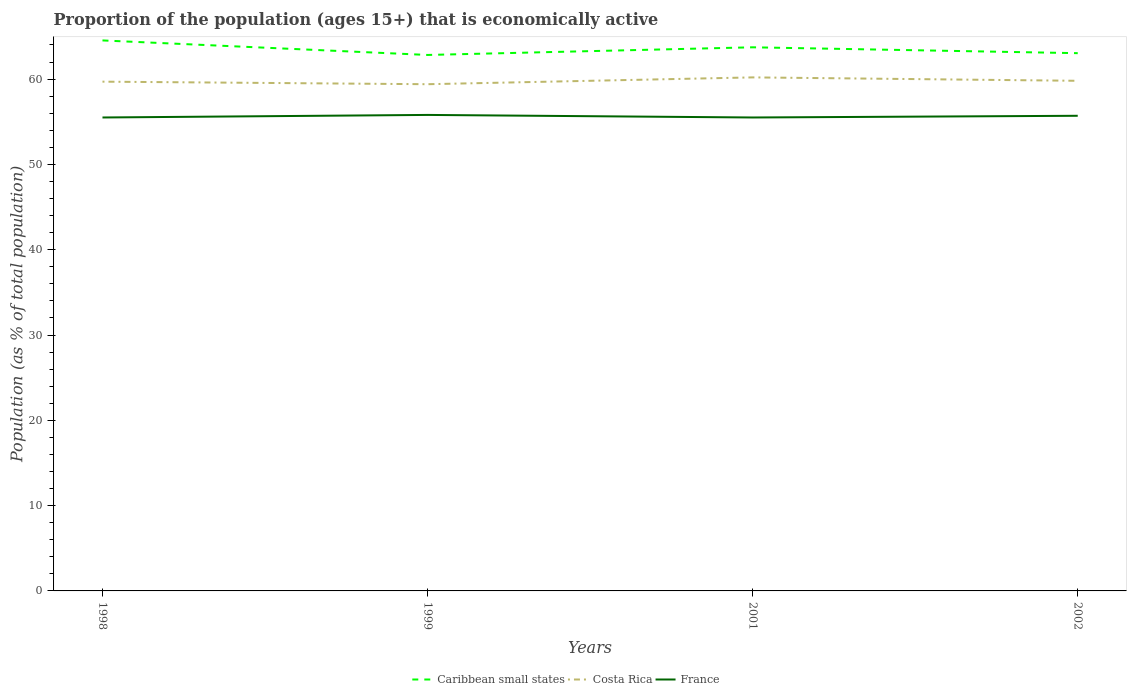How many different coloured lines are there?
Your answer should be compact. 3. Across all years, what is the maximum proportion of the population that is economically active in Costa Rica?
Make the answer very short. 59.4. What is the total proportion of the population that is economically active in France in the graph?
Offer a terse response. -0.2. What is the difference between the highest and the second highest proportion of the population that is economically active in France?
Your answer should be compact. 0.3. What is the difference between the highest and the lowest proportion of the population that is economically active in Caribbean small states?
Your answer should be very brief. 2. Is the proportion of the population that is economically active in France strictly greater than the proportion of the population that is economically active in Costa Rica over the years?
Your answer should be very brief. Yes. How many lines are there?
Offer a very short reply. 3. How many years are there in the graph?
Keep it short and to the point. 4. What is the difference between two consecutive major ticks on the Y-axis?
Ensure brevity in your answer.  10. Are the values on the major ticks of Y-axis written in scientific E-notation?
Offer a very short reply. No. How many legend labels are there?
Make the answer very short. 3. What is the title of the graph?
Offer a terse response. Proportion of the population (ages 15+) that is economically active. What is the label or title of the Y-axis?
Offer a terse response. Population (as % of total population). What is the Population (as % of total population) in Caribbean small states in 1998?
Your answer should be compact. 64.53. What is the Population (as % of total population) in Costa Rica in 1998?
Provide a succinct answer. 59.7. What is the Population (as % of total population) of France in 1998?
Your answer should be very brief. 55.5. What is the Population (as % of total population) in Caribbean small states in 1999?
Offer a terse response. 62.83. What is the Population (as % of total population) in Costa Rica in 1999?
Provide a short and direct response. 59.4. What is the Population (as % of total population) in France in 1999?
Keep it short and to the point. 55.8. What is the Population (as % of total population) in Caribbean small states in 2001?
Provide a short and direct response. 63.73. What is the Population (as % of total population) in Costa Rica in 2001?
Make the answer very short. 60.2. What is the Population (as % of total population) in France in 2001?
Give a very brief answer. 55.5. What is the Population (as % of total population) of Caribbean small states in 2002?
Give a very brief answer. 63.04. What is the Population (as % of total population) of Costa Rica in 2002?
Your answer should be compact. 59.8. What is the Population (as % of total population) in France in 2002?
Keep it short and to the point. 55.7. Across all years, what is the maximum Population (as % of total population) in Caribbean small states?
Keep it short and to the point. 64.53. Across all years, what is the maximum Population (as % of total population) of Costa Rica?
Keep it short and to the point. 60.2. Across all years, what is the maximum Population (as % of total population) in France?
Offer a terse response. 55.8. Across all years, what is the minimum Population (as % of total population) of Caribbean small states?
Provide a succinct answer. 62.83. Across all years, what is the minimum Population (as % of total population) in Costa Rica?
Offer a terse response. 59.4. Across all years, what is the minimum Population (as % of total population) of France?
Your response must be concise. 55.5. What is the total Population (as % of total population) of Caribbean small states in the graph?
Provide a succinct answer. 254.13. What is the total Population (as % of total population) in Costa Rica in the graph?
Make the answer very short. 239.1. What is the total Population (as % of total population) in France in the graph?
Make the answer very short. 222.5. What is the difference between the Population (as % of total population) of Caribbean small states in 1998 and that in 1999?
Make the answer very short. 1.7. What is the difference between the Population (as % of total population) in Caribbean small states in 1998 and that in 2001?
Your answer should be very brief. 0.81. What is the difference between the Population (as % of total population) in Caribbean small states in 1998 and that in 2002?
Your answer should be compact. 1.49. What is the difference between the Population (as % of total population) in Caribbean small states in 1999 and that in 2001?
Your answer should be very brief. -0.9. What is the difference between the Population (as % of total population) in Caribbean small states in 1999 and that in 2002?
Provide a short and direct response. -0.21. What is the difference between the Population (as % of total population) of Costa Rica in 1999 and that in 2002?
Offer a very short reply. -0.4. What is the difference between the Population (as % of total population) of Caribbean small states in 2001 and that in 2002?
Provide a short and direct response. 0.69. What is the difference between the Population (as % of total population) of Costa Rica in 2001 and that in 2002?
Your answer should be compact. 0.4. What is the difference between the Population (as % of total population) in Caribbean small states in 1998 and the Population (as % of total population) in Costa Rica in 1999?
Your response must be concise. 5.13. What is the difference between the Population (as % of total population) in Caribbean small states in 1998 and the Population (as % of total population) in France in 1999?
Provide a short and direct response. 8.73. What is the difference between the Population (as % of total population) in Caribbean small states in 1998 and the Population (as % of total population) in Costa Rica in 2001?
Give a very brief answer. 4.33. What is the difference between the Population (as % of total population) of Caribbean small states in 1998 and the Population (as % of total population) of France in 2001?
Offer a very short reply. 9.03. What is the difference between the Population (as % of total population) of Costa Rica in 1998 and the Population (as % of total population) of France in 2001?
Your answer should be very brief. 4.2. What is the difference between the Population (as % of total population) of Caribbean small states in 1998 and the Population (as % of total population) of Costa Rica in 2002?
Provide a short and direct response. 4.73. What is the difference between the Population (as % of total population) of Caribbean small states in 1998 and the Population (as % of total population) of France in 2002?
Provide a succinct answer. 8.83. What is the difference between the Population (as % of total population) in Costa Rica in 1998 and the Population (as % of total population) in France in 2002?
Keep it short and to the point. 4. What is the difference between the Population (as % of total population) of Caribbean small states in 1999 and the Population (as % of total population) of Costa Rica in 2001?
Your answer should be compact. 2.63. What is the difference between the Population (as % of total population) in Caribbean small states in 1999 and the Population (as % of total population) in France in 2001?
Offer a very short reply. 7.33. What is the difference between the Population (as % of total population) of Caribbean small states in 1999 and the Population (as % of total population) of Costa Rica in 2002?
Make the answer very short. 3.03. What is the difference between the Population (as % of total population) in Caribbean small states in 1999 and the Population (as % of total population) in France in 2002?
Make the answer very short. 7.13. What is the difference between the Population (as % of total population) in Costa Rica in 1999 and the Population (as % of total population) in France in 2002?
Your response must be concise. 3.7. What is the difference between the Population (as % of total population) in Caribbean small states in 2001 and the Population (as % of total population) in Costa Rica in 2002?
Provide a succinct answer. 3.93. What is the difference between the Population (as % of total population) of Caribbean small states in 2001 and the Population (as % of total population) of France in 2002?
Offer a terse response. 8.03. What is the difference between the Population (as % of total population) in Costa Rica in 2001 and the Population (as % of total population) in France in 2002?
Your response must be concise. 4.5. What is the average Population (as % of total population) in Caribbean small states per year?
Ensure brevity in your answer.  63.53. What is the average Population (as % of total population) of Costa Rica per year?
Provide a short and direct response. 59.77. What is the average Population (as % of total population) in France per year?
Make the answer very short. 55.62. In the year 1998, what is the difference between the Population (as % of total population) in Caribbean small states and Population (as % of total population) in Costa Rica?
Provide a short and direct response. 4.83. In the year 1998, what is the difference between the Population (as % of total population) in Caribbean small states and Population (as % of total population) in France?
Provide a short and direct response. 9.03. In the year 1998, what is the difference between the Population (as % of total population) of Costa Rica and Population (as % of total population) of France?
Keep it short and to the point. 4.2. In the year 1999, what is the difference between the Population (as % of total population) of Caribbean small states and Population (as % of total population) of Costa Rica?
Ensure brevity in your answer.  3.43. In the year 1999, what is the difference between the Population (as % of total population) in Caribbean small states and Population (as % of total population) in France?
Provide a succinct answer. 7.03. In the year 2001, what is the difference between the Population (as % of total population) in Caribbean small states and Population (as % of total population) in Costa Rica?
Your answer should be very brief. 3.53. In the year 2001, what is the difference between the Population (as % of total population) in Caribbean small states and Population (as % of total population) in France?
Provide a short and direct response. 8.23. In the year 2001, what is the difference between the Population (as % of total population) of Costa Rica and Population (as % of total population) of France?
Keep it short and to the point. 4.7. In the year 2002, what is the difference between the Population (as % of total population) of Caribbean small states and Population (as % of total population) of Costa Rica?
Provide a succinct answer. 3.24. In the year 2002, what is the difference between the Population (as % of total population) in Caribbean small states and Population (as % of total population) in France?
Offer a very short reply. 7.34. In the year 2002, what is the difference between the Population (as % of total population) of Costa Rica and Population (as % of total population) of France?
Provide a short and direct response. 4.1. What is the ratio of the Population (as % of total population) of Caribbean small states in 1998 to that in 1999?
Provide a short and direct response. 1.03. What is the ratio of the Population (as % of total population) of Caribbean small states in 1998 to that in 2001?
Provide a short and direct response. 1.01. What is the ratio of the Population (as % of total population) of Costa Rica in 1998 to that in 2001?
Make the answer very short. 0.99. What is the ratio of the Population (as % of total population) of Caribbean small states in 1998 to that in 2002?
Ensure brevity in your answer.  1.02. What is the ratio of the Population (as % of total population) of Caribbean small states in 1999 to that in 2001?
Your response must be concise. 0.99. What is the ratio of the Population (as % of total population) of Costa Rica in 1999 to that in 2001?
Offer a very short reply. 0.99. What is the ratio of the Population (as % of total population) of France in 1999 to that in 2001?
Provide a short and direct response. 1.01. What is the ratio of the Population (as % of total population) of France in 1999 to that in 2002?
Your response must be concise. 1. What is the ratio of the Population (as % of total population) of Caribbean small states in 2001 to that in 2002?
Your response must be concise. 1.01. What is the ratio of the Population (as % of total population) of France in 2001 to that in 2002?
Keep it short and to the point. 1. What is the difference between the highest and the second highest Population (as % of total population) of Caribbean small states?
Offer a very short reply. 0.81. What is the difference between the highest and the second highest Population (as % of total population) of Costa Rica?
Provide a short and direct response. 0.4. What is the difference between the highest and the second highest Population (as % of total population) of France?
Offer a very short reply. 0.1. What is the difference between the highest and the lowest Population (as % of total population) of Caribbean small states?
Keep it short and to the point. 1.7. What is the difference between the highest and the lowest Population (as % of total population) in France?
Provide a short and direct response. 0.3. 